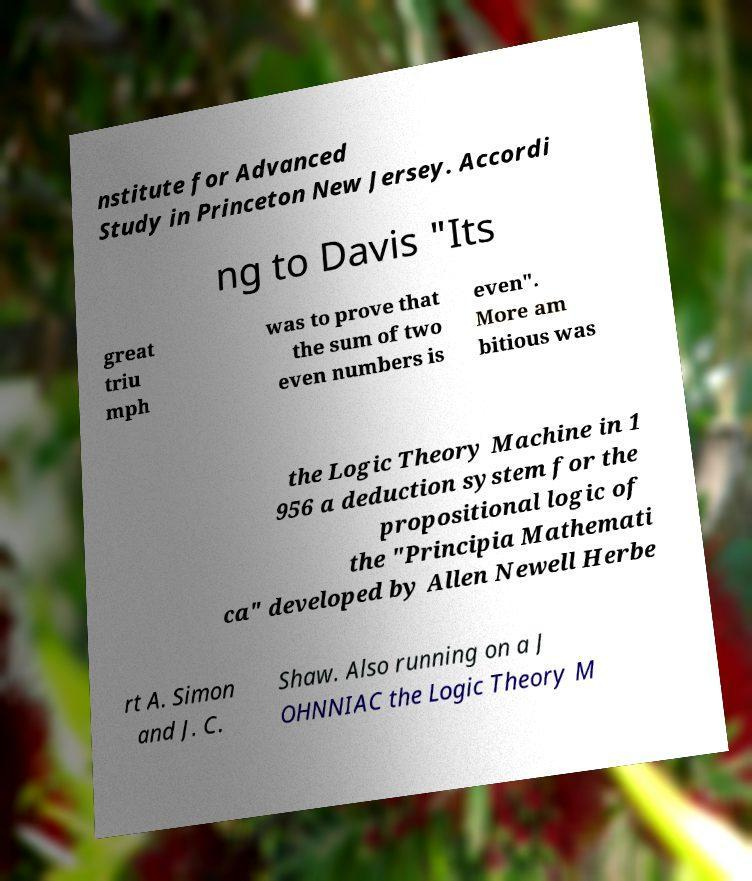Please read and relay the text visible in this image. What does it say? nstitute for Advanced Study in Princeton New Jersey. Accordi ng to Davis "Its great triu mph was to prove that the sum of two even numbers is even". More am bitious was the Logic Theory Machine in 1 956 a deduction system for the propositional logic of the "Principia Mathemati ca" developed by Allen Newell Herbe rt A. Simon and J. C. Shaw. Also running on a J OHNNIAC the Logic Theory M 